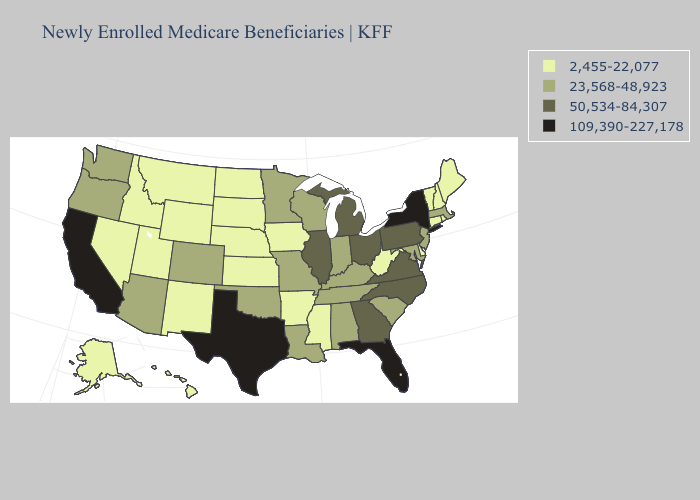What is the lowest value in the MidWest?
Quick response, please. 2,455-22,077. Among the states that border Alabama , which have the highest value?
Answer briefly. Florida. Does Hawaii have a higher value than North Dakota?
Short answer required. No. Does North Dakota have the lowest value in the MidWest?
Quick response, please. Yes. Name the states that have a value in the range 2,455-22,077?
Short answer required. Alaska, Arkansas, Connecticut, Delaware, Hawaii, Idaho, Iowa, Kansas, Maine, Mississippi, Montana, Nebraska, Nevada, New Hampshire, New Mexico, North Dakota, Rhode Island, South Dakota, Utah, Vermont, West Virginia, Wyoming. What is the highest value in the USA?
Write a very short answer. 109,390-227,178. How many symbols are there in the legend?
Quick response, please. 4. Which states have the highest value in the USA?
Give a very brief answer. California, Florida, New York, Texas. Which states have the lowest value in the USA?
Short answer required. Alaska, Arkansas, Connecticut, Delaware, Hawaii, Idaho, Iowa, Kansas, Maine, Mississippi, Montana, Nebraska, Nevada, New Hampshire, New Mexico, North Dakota, Rhode Island, South Dakota, Utah, Vermont, West Virginia, Wyoming. Name the states that have a value in the range 2,455-22,077?
Give a very brief answer. Alaska, Arkansas, Connecticut, Delaware, Hawaii, Idaho, Iowa, Kansas, Maine, Mississippi, Montana, Nebraska, Nevada, New Hampshire, New Mexico, North Dakota, Rhode Island, South Dakota, Utah, Vermont, West Virginia, Wyoming. Name the states that have a value in the range 23,568-48,923?
Short answer required. Alabama, Arizona, Colorado, Indiana, Kentucky, Louisiana, Maryland, Massachusetts, Minnesota, Missouri, New Jersey, Oklahoma, Oregon, South Carolina, Tennessee, Washington, Wisconsin. What is the lowest value in the MidWest?
Be succinct. 2,455-22,077. Does Connecticut have the highest value in the Northeast?
Give a very brief answer. No. Among the states that border Washington , which have the lowest value?
Answer briefly. Idaho. Name the states that have a value in the range 2,455-22,077?
Keep it brief. Alaska, Arkansas, Connecticut, Delaware, Hawaii, Idaho, Iowa, Kansas, Maine, Mississippi, Montana, Nebraska, Nevada, New Hampshire, New Mexico, North Dakota, Rhode Island, South Dakota, Utah, Vermont, West Virginia, Wyoming. 